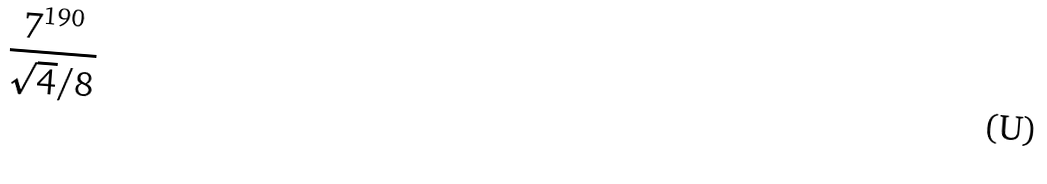Convert formula to latex. <formula><loc_0><loc_0><loc_500><loc_500>\frac { 7 ^ { 1 9 0 } } { \sqrt { 4 } / 8 }</formula> 